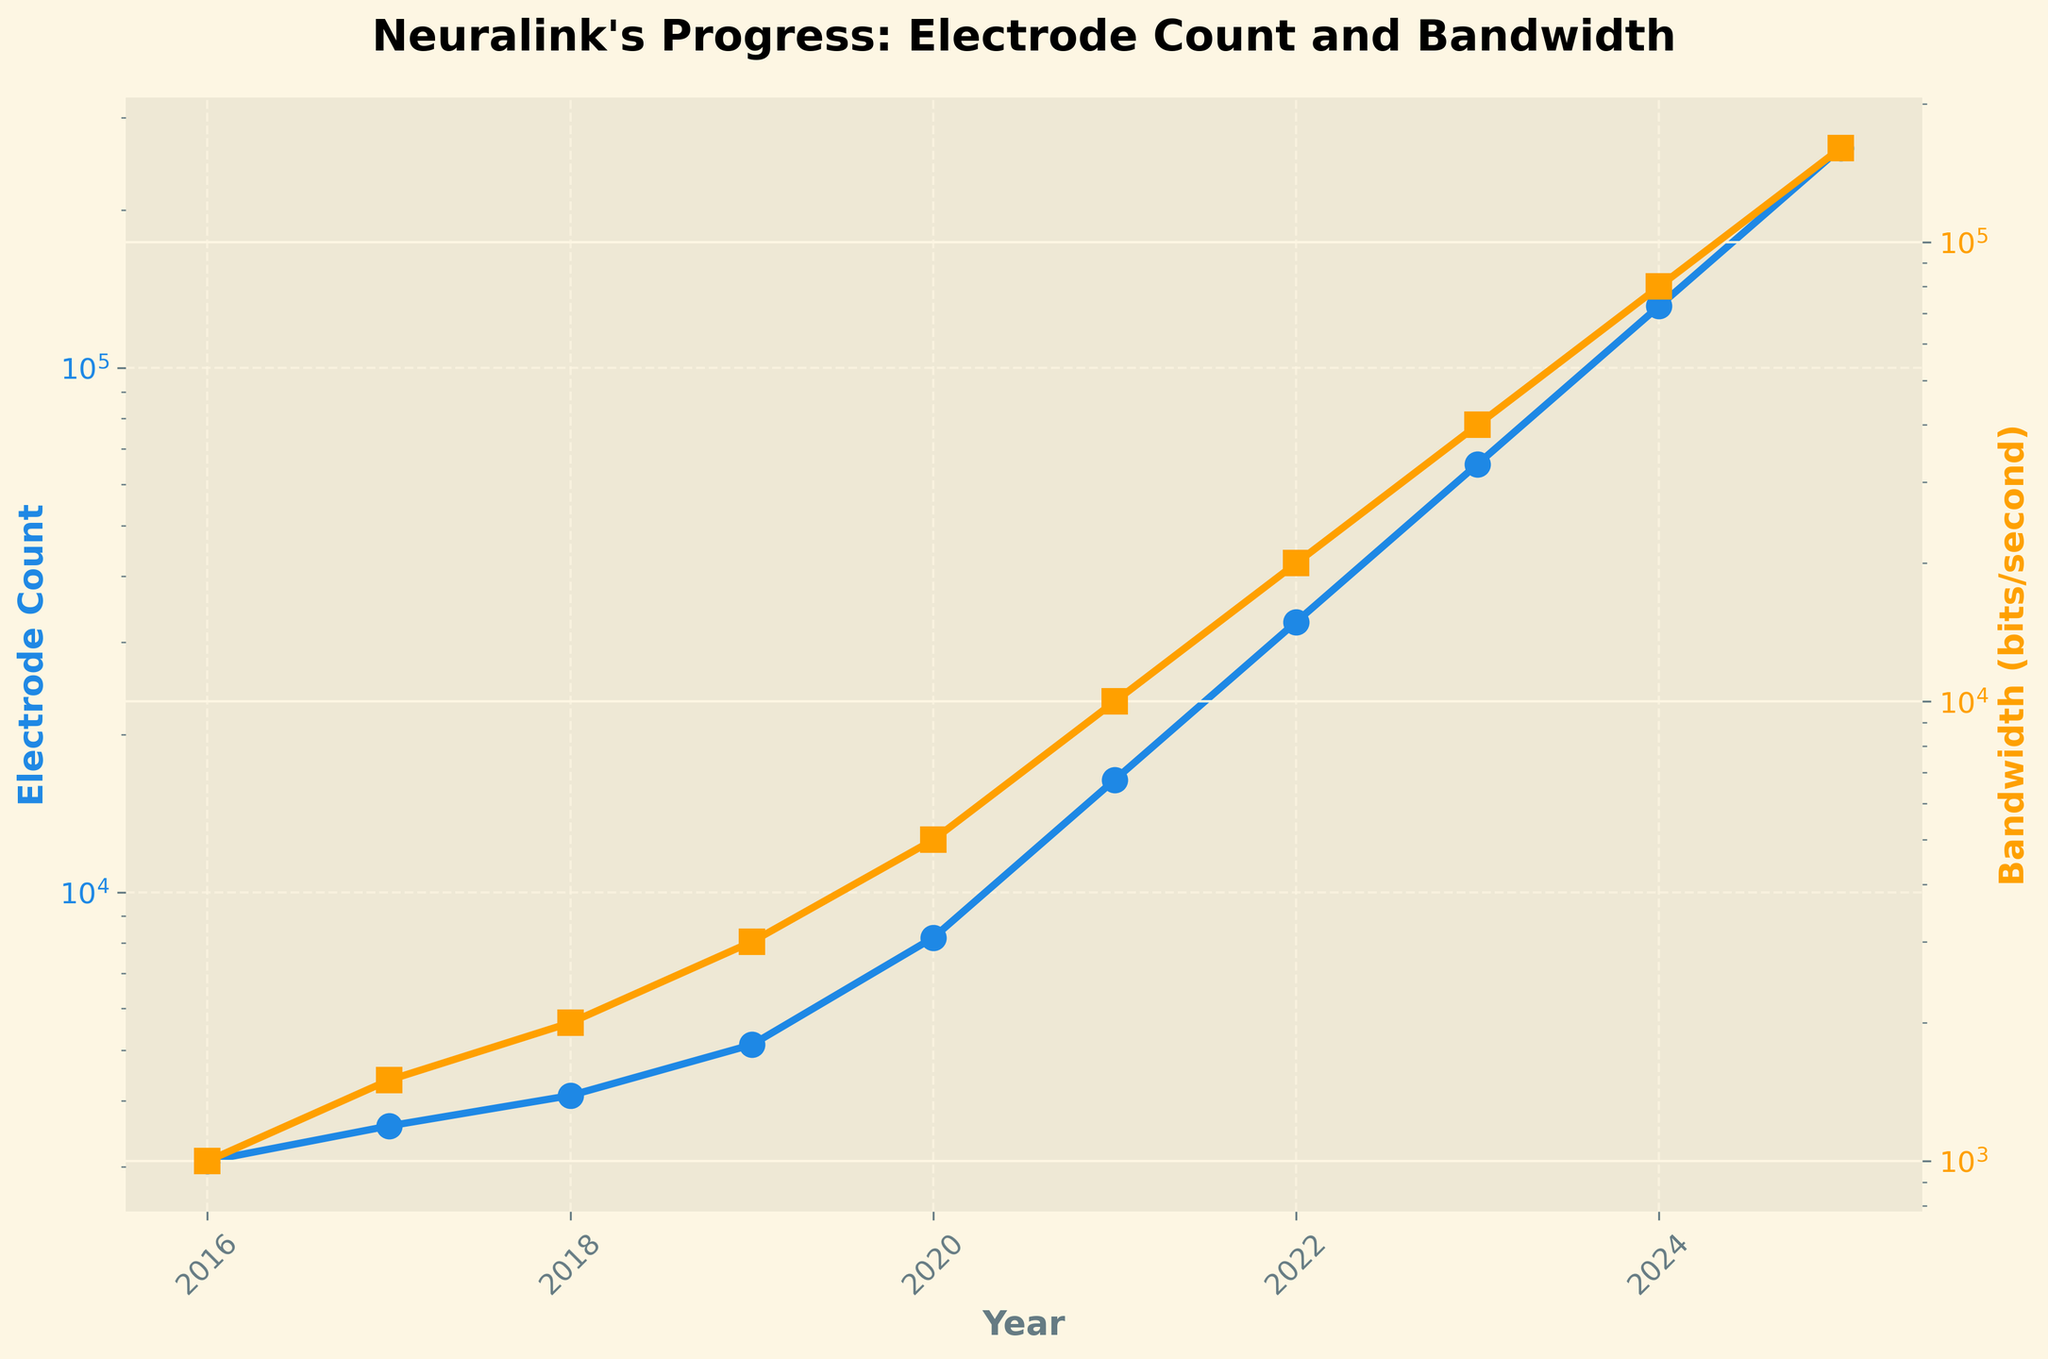What's the electrode count in 2020? The electrode count for each year is indicated by the blue line with circle markers. By looking at the year 2020 on the x-axis and following the blue line upwards, we find the corresponding value.
Answer: 8192 How much did the bandwidth increase from 2021 to 2023? The bandwidth in 2021 is indicated by the yellow line with square markers at 10,000 bits/second. For 2023, it is 40,000 bits/second. The increase is calculated by subtracting the 2021 value from the 2023 value (40,000 - 10,000).
Answer: 30,000 bits/second By what factor did the electrode count increase from 2016 to 2025? In 2016, the electrode count is 3,072, and in 2025, it is 262,144. The factor of increase is calculated by dividing the 2025 value by the 2016 value (262,144 / 3,072).
Answer: 85 Compare the growth rates of electrode count and bandwidth from 2019 to 2020. Which grew more rapidly? The electrode count grew from 5,120 to 8,192, which is (8,192 - 5,120) = 3,072. The bandwidth grew from 3,000 to 5,000 bits/second, which is (5,000 - 3,000) = 2,000 bits/second. Comparing these two absolute growths, the electrode count grew by 3,072 and the bandwidth by 2,000.
Answer: Electrode count What is the median electrode count from 2016 to 2025? The electrode counts from 2016 to 2025 are: [3,072, 3,584, 4,096, 5,120, 8,192, 16,384, 32,768, 65,536, 131,072, 262,144]. Since there are 10 data points, the median is the average of the 5th and 6th values. ((8,192 + 16,384) / 2).
Answer: 12,288 By what percentage did the bandwidth improve from 2018 to 2022? In 2018, the bandwidth was 2,000 bits/second. In 2022, it was 20,000 bits/second. The percentage increase is calculated by ((20,000 - 2,000) / 2,000) * 100.
Answer: 900% Which year did the electrode count first exceed 10,000? By inspecting the blue line with circle markers, we see that the electrode count first exceeds 10,000 in the year 2021.
Answer: 2021 Is the bandwidth growing faster logarithmically or linearly over the years? The yellow line with square markers shows the bandwidth growth. Since the y-axis for both electrode count and bandwidth is logarithmic, linear increases on a logarithmic scale indicate exponential growth. Given the straight-line pattern, the growth is more consistent with exponential (logarithmic on a linear scale).
Answer: Logarithmically How does the visual color distinction of the lines help in understanding the chart? The blue line with circle markers represents electrode counts, and the yellow line with square markers represents bandwidth. The color distinction helps in clearly differentiating between the two types of data being presented, making it easy to track their respective trends over the years.
Answer: Differentiates trends 